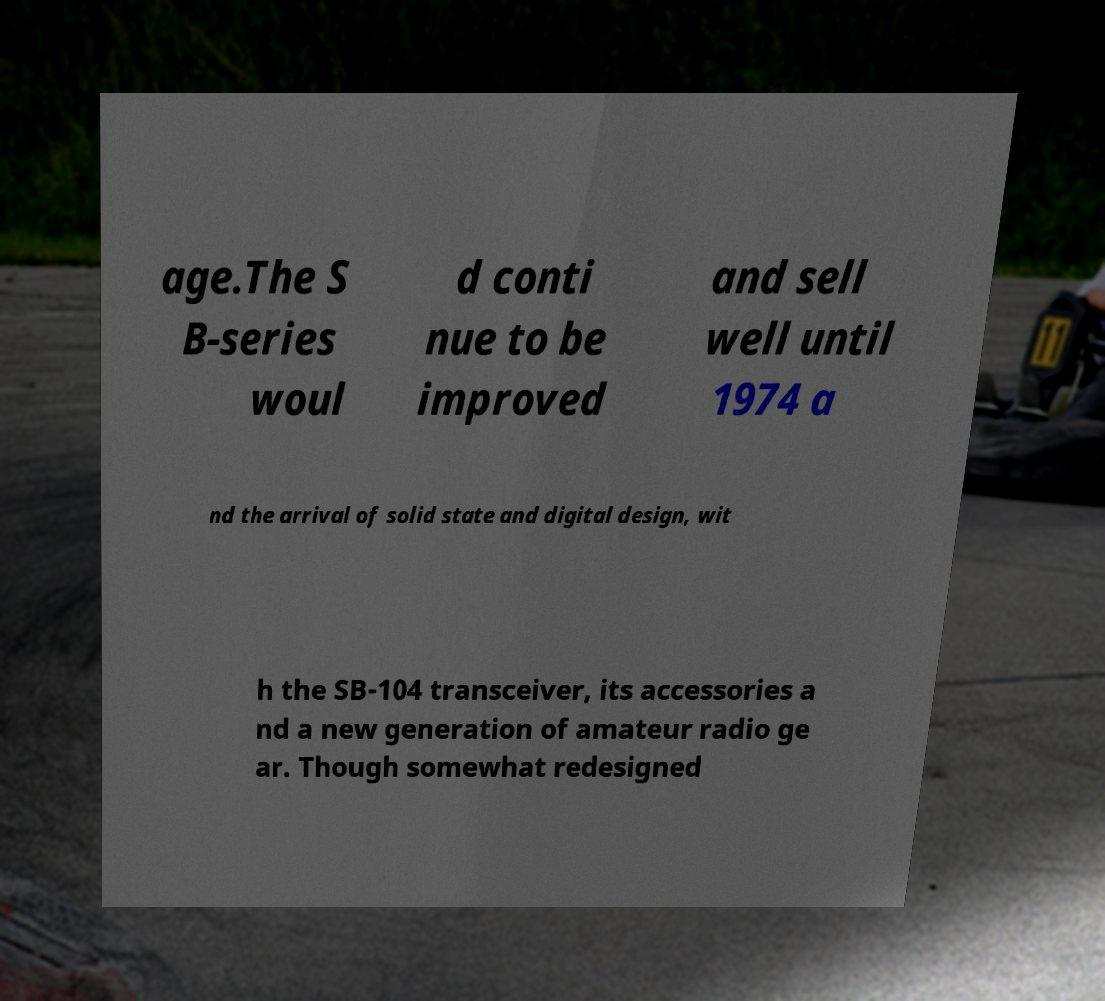For documentation purposes, I need the text within this image transcribed. Could you provide that? age.The S B-series woul d conti nue to be improved and sell well until 1974 a nd the arrival of solid state and digital design, wit h the SB-104 transceiver, its accessories a nd a new generation of amateur radio ge ar. Though somewhat redesigned 